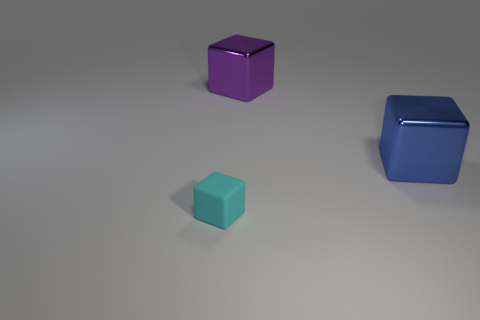Are there any other things that have the same material as the small object? Based on the image, it is not possible to definitively determine the material of any objects due to the lack of detail and texture that would indicate material properties. However, since all objects have a similar matte finish and geometry, it's plausible they could be made from the same kind of material. 